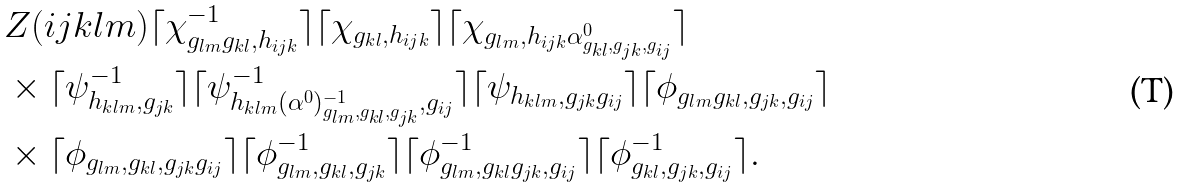<formula> <loc_0><loc_0><loc_500><loc_500>& Z ( i j k l m ) \lceil \chi ^ { - 1 } _ { g _ { l m } g _ { k l } , h _ { i j k } } \rceil \lceil \chi _ { g _ { k l } , h _ { i j k } } \rceil \lceil \chi _ { g _ { l m } , h _ { i j k } \alpha ^ { 0 } _ { g _ { k l } , g _ { j k } , g _ { i j } } } \rceil \\ & \times \lceil \psi ^ { - 1 } _ { h _ { k l m } , g _ { j k } } \rceil \lceil \psi ^ { - 1 } _ { h _ { k l m } ( \alpha ^ { 0 } ) ^ { - 1 } _ { g _ { l m } , g _ { k l } , g _ { j k } } , g _ { i j } } \rceil \lceil \psi _ { h _ { k l m } , g _ { j k } g _ { i j } } \rceil \lceil \phi _ { g _ { l m } g _ { k l } , g _ { j k } , g _ { i j } } \rceil \\ & \times \lceil \phi _ { g _ { l m } , g _ { k l } , g _ { j k } g _ { i j } } \rceil \lceil \phi ^ { - 1 } _ { g _ { l m } , g _ { k l } , g _ { j k } } \rceil \lceil \phi ^ { - 1 } _ { g _ { l m } , g _ { k l } g _ { j k } , g _ { i j } } \rceil \lceil \phi ^ { - 1 } _ { g _ { k l } , g _ { j k } , g _ { i j } } \rceil .</formula> 